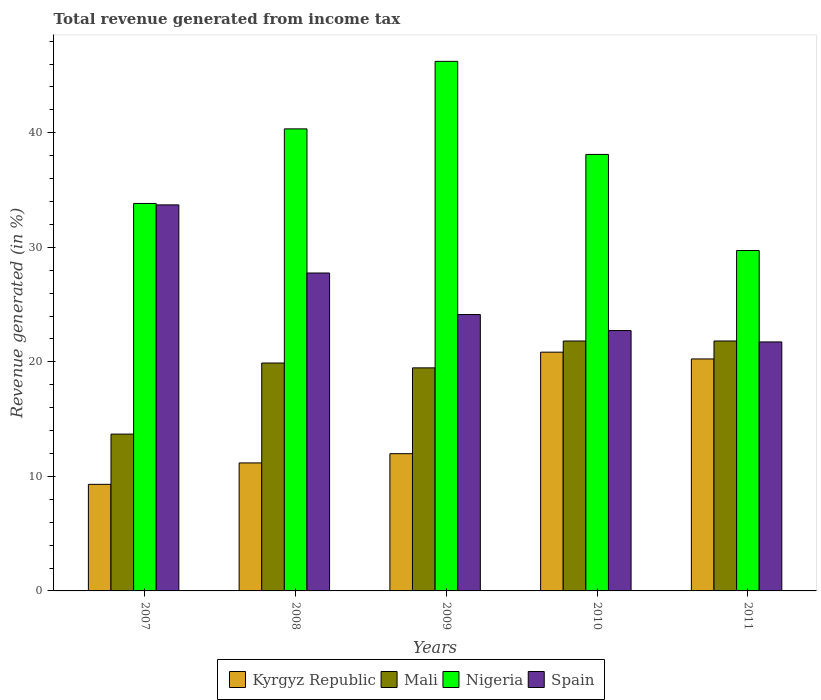Are the number of bars per tick equal to the number of legend labels?
Provide a succinct answer. Yes. Are the number of bars on each tick of the X-axis equal?
Offer a very short reply. Yes. How many bars are there on the 4th tick from the left?
Ensure brevity in your answer.  4. How many bars are there on the 3rd tick from the right?
Keep it short and to the point. 4. What is the label of the 3rd group of bars from the left?
Make the answer very short. 2009. What is the total revenue generated in Mali in 2010?
Keep it short and to the point. 21.82. Across all years, what is the maximum total revenue generated in Mali?
Offer a very short reply. 21.82. Across all years, what is the minimum total revenue generated in Kyrgyz Republic?
Keep it short and to the point. 9.31. What is the total total revenue generated in Spain in the graph?
Keep it short and to the point. 130.06. What is the difference between the total revenue generated in Nigeria in 2009 and that in 2011?
Your answer should be very brief. 16.51. What is the difference between the total revenue generated in Mali in 2011 and the total revenue generated in Kyrgyz Republic in 2009?
Ensure brevity in your answer.  9.84. What is the average total revenue generated in Kyrgyz Republic per year?
Give a very brief answer. 14.71. In the year 2008, what is the difference between the total revenue generated in Mali and total revenue generated in Nigeria?
Ensure brevity in your answer.  -20.44. What is the ratio of the total revenue generated in Nigeria in 2008 to that in 2010?
Your answer should be very brief. 1.06. Is the total revenue generated in Kyrgyz Republic in 2008 less than that in 2011?
Your answer should be compact. Yes. What is the difference between the highest and the second highest total revenue generated in Kyrgyz Republic?
Offer a terse response. 0.59. What is the difference between the highest and the lowest total revenue generated in Nigeria?
Keep it short and to the point. 16.51. In how many years, is the total revenue generated in Kyrgyz Republic greater than the average total revenue generated in Kyrgyz Republic taken over all years?
Offer a terse response. 2. What does the 3rd bar from the left in 2011 represents?
Provide a succinct answer. Nigeria. What does the 4th bar from the right in 2009 represents?
Offer a very short reply. Kyrgyz Republic. Is it the case that in every year, the sum of the total revenue generated in Mali and total revenue generated in Spain is greater than the total revenue generated in Nigeria?
Your answer should be compact. No. Are the values on the major ticks of Y-axis written in scientific E-notation?
Your response must be concise. No. Does the graph contain grids?
Make the answer very short. No. How many legend labels are there?
Your answer should be very brief. 4. What is the title of the graph?
Ensure brevity in your answer.  Total revenue generated from income tax. What is the label or title of the Y-axis?
Give a very brief answer. Revenue generated (in %). What is the Revenue generated (in %) in Kyrgyz Republic in 2007?
Offer a very short reply. 9.31. What is the Revenue generated (in %) of Mali in 2007?
Your answer should be compact. 13.69. What is the Revenue generated (in %) of Nigeria in 2007?
Keep it short and to the point. 33.83. What is the Revenue generated (in %) in Spain in 2007?
Offer a very short reply. 33.7. What is the Revenue generated (in %) in Kyrgyz Republic in 2008?
Provide a succinct answer. 11.17. What is the Revenue generated (in %) of Mali in 2008?
Your answer should be compact. 19.9. What is the Revenue generated (in %) in Nigeria in 2008?
Your response must be concise. 40.34. What is the Revenue generated (in %) in Spain in 2008?
Your response must be concise. 27.76. What is the Revenue generated (in %) in Kyrgyz Republic in 2009?
Provide a succinct answer. 11.98. What is the Revenue generated (in %) in Mali in 2009?
Provide a succinct answer. 19.47. What is the Revenue generated (in %) in Nigeria in 2009?
Your answer should be very brief. 46.23. What is the Revenue generated (in %) in Spain in 2009?
Ensure brevity in your answer.  24.13. What is the Revenue generated (in %) in Kyrgyz Republic in 2010?
Provide a succinct answer. 20.84. What is the Revenue generated (in %) in Mali in 2010?
Provide a succinct answer. 21.82. What is the Revenue generated (in %) of Nigeria in 2010?
Provide a short and direct response. 38.11. What is the Revenue generated (in %) of Spain in 2010?
Make the answer very short. 22.73. What is the Revenue generated (in %) of Kyrgyz Republic in 2011?
Offer a very short reply. 20.25. What is the Revenue generated (in %) in Mali in 2011?
Provide a short and direct response. 21.82. What is the Revenue generated (in %) of Nigeria in 2011?
Your answer should be compact. 29.72. What is the Revenue generated (in %) of Spain in 2011?
Make the answer very short. 21.74. Across all years, what is the maximum Revenue generated (in %) in Kyrgyz Republic?
Make the answer very short. 20.84. Across all years, what is the maximum Revenue generated (in %) of Mali?
Make the answer very short. 21.82. Across all years, what is the maximum Revenue generated (in %) of Nigeria?
Give a very brief answer. 46.23. Across all years, what is the maximum Revenue generated (in %) of Spain?
Your answer should be very brief. 33.7. Across all years, what is the minimum Revenue generated (in %) in Kyrgyz Republic?
Offer a terse response. 9.31. Across all years, what is the minimum Revenue generated (in %) in Mali?
Keep it short and to the point. 13.69. Across all years, what is the minimum Revenue generated (in %) in Nigeria?
Make the answer very short. 29.72. Across all years, what is the minimum Revenue generated (in %) in Spain?
Provide a short and direct response. 21.74. What is the total Revenue generated (in %) in Kyrgyz Republic in the graph?
Your answer should be compact. 73.56. What is the total Revenue generated (in %) of Mali in the graph?
Provide a short and direct response. 96.7. What is the total Revenue generated (in %) in Nigeria in the graph?
Your answer should be compact. 188.22. What is the total Revenue generated (in %) in Spain in the graph?
Offer a terse response. 130.06. What is the difference between the Revenue generated (in %) of Kyrgyz Republic in 2007 and that in 2008?
Ensure brevity in your answer.  -1.87. What is the difference between the Revenue generated (in %) in Mali in 2007 and that in 2008?
Give a very brief answer. -6.2. What is the difference between the Revenue generated (in %) of Nigeria in 2007 and that in 2008?
Your answer should be compact. -6.51. What is the difference between the Revenue generated (in %) in Spain in 2007 and that in 2008?
Give a very brief answer. 5.95. What is the difference between the Revenue generated (in %) of Kyrgyz Republic in 2007 and that in 2009?
Provide a succinct answer. -2.68. What is the difference between the Revenue generated (in %) in Mali in 2007 and that in 2009?
Keep it short and to the point. -5.78. What is the difference between the Revenue generated (in %) in Nigeria in 2007 and that in 2009?
Your answer should be compact. -12.41. What is the difference between the Revenue generated (in %) in Spain in 2007 and that in 2009?
Provide a succinct answer. 9.57. What is the difference between the Revenue generated (in %) in Kyrgyz Republic in 2007 and that in 2010?
Ensure brevity in your answer.  -11.54. What is the difference between the Revenue generated (in %) in Mali in 2007 and that in 2010?
Provide a succinct answer. -8.13. What is the difference between the Revenue generated (in %) of Nigeria in 2007 and that in 2010?
Your answer should be compact. -4.28. What is the difference between the Revenue generated (in %) of Spain in 2007 and that in 2010?
Your answer should be very brief. 10.97. What is the difference between the Revenue generated (in %) in Kyrgyz Republic in 2007 and that in 2011?
Provide a short and direct response. -10.95. What is the difference between the Revenue generated (in %) of Mali in 2007 and that in 2011?
Offer a very short reply. -8.13. What is the difference between the Revenue generated (in %) of Nigeria in 2007 and that in 2011?
Provide a short and direct response. 4.11. What is the difference between the Revenue generated (in %) of Spain in 2007 and that in 2011?
Provide a short and direct response. 11.97. What is the difference between the Revenue generated (in %) in Kyrgyz Republic in 2008 and that in 2009?
Keep it short and to the point. -0.81. What is the difference between the Revenue generated (in %) of Mali in 2008 and that in 2009?
Offer a terse response. 0.42. What is the difference between the Revenue generated (in %) of Nigeria in 2008 and that in 2009?
Offer a very short reply. -5.9. What is the difference between the Revenue generated (in %) in Spain in 2008 and that in 2009?
Provide a succinct answer. 3.62. What is the difference between the Revenue generated (in %) of Kyrgyz Republic in 2008 and that in 2010?
Ensure brevity in your answer.  -9.67. What is the difference between the Revenue generated (in %) in Mali in 2008 and that in 2010?
Offer a terse response. -1.92. What is the difference between the Revenue generated (in %) in Nigeria in 2008 and that in 2010?
Your answer should be very brief. 2.23. What is the difference between the Revenue generated (in %) of Spain in 2008 and that in 2010?
Keep it short and to the point. 5.02. What is the difference between the Revenue generated (in %) of Kyrgyz Republic in 2008 and that in 2011?
Ensure brevity in your answer.  -9.08. What is the difference between the Revenue generated (in %) of Mali in 2008 and that in 2011?
Offer a very short reply. -1.92. What is the difference between the Revenue generated (in %) of Nigeria in 2008 and that in 2011?
Keep it short and to the point. 10.62. What is the difference between the Revenue generated (in %) of Spain in 2008 and that in 2011?
Ensure brevity in your answer.  6.02. What is the difference between the Revenue generated (in %) in Kyrgyz Republic in 2009 and that in 2010?
Provide a succinct answer. -8.86. What is the difference between the Revenue generated (in %) of Mali in 2009 and that in 2010?
Give a very brief answer. -2.35. What is the difference between the Revenue generated (in %) of Nigeria in 2009 and that in 2010?
Your answer should be compact. 8.13. What is the difference between the Revenue generated (in %) in Spain in 2009 and that in 2010?
Offer a terse response. 1.4. What is the difference between the Revenue generated (in %) in Kyrgyz Republic in 2009 and that in 2011?
Keep it short and to the point. -8.27. What is the difference between the Revenue generated (in %) of Mali in 2009 and that in 2011?
Your response must be concise. -2.35. What is the difference between the Revenue generated (in %) in Nigeria in 2009 and that in 2011?
Give a very brief answer. 16.51. What is the difference between the Revenue generated (in %) in Spain in 2009 and that in 2011?
Your answer should be very brief. 2.39. What is the difference between the Revenue generated (in %) in Kyrgyz Republic in 2010 and that in 2011?
Offer a terse response. 0.59. What is the difference between the Revenue generated (in %) of Mali in 2010 and that in 2011?
Your answer should be very brief. -0. What is the difference between the Revenue generated (in %) in Nigeria in 2010 and that in 2011?
Provide a short and direct response. 8.39. What is the difference between the Revenue generated (in %) in Kyrgyz Republic in 2007 and the Revenue generated (in %) in Mali in 2008?
Your answer should be very brief. -10.59. What is the difference between the Revenue generated (in %) of Kyrgyz Republic in 2007 and the Revenue generated (in %) of Nigeria in 2008?
Your answer should be very brief. -31.03. What is the difference between the Revenue generated (in %) of Kyrgyz Republic in 2007 and the Revenue generated (in %) of Spain in 2008?
Make the answer very short. -18.45. What is the difference between the Revenue generated (in %) in Mali in 2007 and the Revenue generated (in %) in Nigeria in 2008?
Provide a short and direct response. -26.65. What is the difference between the Revenue generated (in %) of Mali in 2007 and the Revenue generated (in %) of Spain in 2008?
Your answer should be very brief. -14.06. What is the difference between the Revenue generated (in %) in Nigeria in 2007 and the Revenue generated (in %) in Spain in 2008?
Your answer should be compact. 6.07. What is the difference between the Revenue generated (in %) in Kyrgyz Republic in 2007 and the Revenue generated (in %) in Mali in 2009?
Keep it short and to the point. -10.17. What is the difference between the Revenue generated (in %) of Kyrgyz Republic in 2007 and the Revenue generated (in %) of Nigeria in 2009?
Provide a short and direct response. -36.93. What is the difference between the Revenue generated (in %) in Kyrgyz Republic in 2007 and the Revenue generated (in %) in Spain in 2009?
Your answer should be compact. -14.83. What is the difference between the Revenue generated (in %) of Mali in 2007 and the Revenue generated (in %) of Nigeria in 2009?
Provide a succinct answer. -32.54. What is the difference between the Revenue generated (in %) of Mali in 2007 and the Revenue generated (in %) of Spain in 2009?
Provide a succinct answer. -10.44. What is the difference between the Revenue generated (in %) in Nigeria in 2007 and the Revenue generated (in %) in Spain in 2009?
Your answer should be compact. 9.7. What is the difference between the Revenue generated (in %) in Kyrgyz Republic in 2007 and the Revenue generated (in %) in Mali in 2010?
Offer a very short reply. -12.51. What is the difference between the Revenue generated (in %) of Kyrgyz Republic in 2007 and the Revenue generated (in %) of Nigeria in 2010?
Your response must be concise. -28.8. What is the difference between the Revenue generated (in %) of Kyrgyz Republic in 2007 and the Revenue generated (in %) of Spain in 2010?
Offer a terse response. -13.42. What is the difference between the Revenue generated (in %) of Mali in 2007 and the Revenue generated (in %) of Nigeria in 2010?
Provide a short and direct response. -24.42. What is the difference between the Revenue generated (in %) in Mali in 2007 and the Revenue generated (in %) in Spain in 2010?
Your answer should be compact. -9.04. What is the difference between the Revenue generated (in %) of Nigeria in 2007 and the Revenue generated (in %) of Spain in 2010?
Your answer should be compact. 11.1. What is the difference between the Revenue generated (in %) of Kyrgyz Republic in 2007 and the Revenue generated (in %) of Mali in 2011?
Your response must be concise. -12.51. What is the difference between the Revenue generated (in %) in Kyrgyz Republic in 2007 and the Revenue generated (in %) in Nigeria in 2011?
Ensure brevity in your answer.  -20.41. What is the difference between the Revenue generated (in %) in Kyrgyz Republic in 2007 and the Revenue generated (in %) in Spain in 2011?
Your response must be concise. -12.43. What is the difference between the Revenue generated (in %) in Mali in 2007 and the Revenue generated (in %) in Nigeria in 2011?
Ensure brevity in your answer.  -16.03. What is the difference between the Revenue generated (in %) of Mali in 2007 and the Revenue generated (in %) of Spain in 2011?
Your response must be concise. -8.05. What is the difference between the Revenue generated (in %) in Nigeria in 2007 and the Revenue generated (in %) in Spain in 2011?
Offer a very short reply. 12.09. What is the difference between the Revenue generated (in %) of Kyrgyz Republic in 2008 and the Revenue generated (in %) of Mali in 2009?
Keep it short and to the point. -8.3. What is the difference between the Revenue generated (in %) in Kyrgyz Republic in 2008 and the Revenue generated (in %) in Nigeria in 2009?
Keep it short and to the point. -35.06. What is the difference between the Revenue generated (in %) in Kyrgyz Republic in 2008 and the Revenue generated (in %) in Spain in 2009?
Your answer should be compact. -12.96. What is the difference between the Revenue generated (in %) of Mali in 2008 and the Revenue generated (in %) of Nigeria in 2009?
Your answer should be compact. -26.34. What is the difference between the Revenue generated (in %) in Mali in 2008 and the Revenue generated (in %) in Spain in 2009?
Your answer should be very brief. -4.23. What is the difference between the Revenue generated (in %) in Nigeria in 2008 and the Revenue generated (in %) in Spain in 2009?
Your answer should be compact. 16.21. What is the difference between the Revenue generated (in %) in Kyrgyz Republic in 2008 and the Revenue generated (in %) in Mali in 2010?
Ensure brevity in your answer.  -10.64. What is the difference between the Revenue generated (in %) in Kyrgyz Republic in 2008 and the Revenue generated (in %) in Nigeria in 2010?
Offer a very short reply. -26.93. What is the difference between the Revenue generated (in %) of Kyrgyz Republic in 2008 and the Revenue generated (in %) of Spain in 2010?
Provide a short and direct response. -11.56. What is the difference between the Revenue generated (in %) of Mali in 2008 and the Revenue generated (in %) of Nigeria in 2010?
Offer a very short reply. -18.21. What is the difference between the Revenue generated (in %) of Mali in 2008 and the Revenue generated (in %) of Spain in 2010?
Offer a terse response. -2.83. What is the difference between the Revenue generated (in %) of Nigeria in 2008 and the Revenue generated (in %) of Spain in 2010?
Give a very brief answer. 17.61. What is the difference between the Revenue generated (in %) of Kyrgyz Republic in 2008 and the Revenue generated (in %) of Mali in 2011?
Your response must be concise. -10.64. What is the difference between the Revenue generated (in %) of Kyrgyz Republic in 2008 and the Revenue generated (in %) of Nigeria in 2011?
Your answer should be very brief. -18.55. What is the difference between the Revenue generated (in %) in Kyrgyz Republic in 2008 and the Revenue generated (in %) in Spain in 2011?
Ensure brevity in your answer.  -10.56. What is the difference between the Revenue generated (in %) of Mali in 2008 and the Revenue generated (in %) of Nigeria in 2011?
Ensure brevity in your answer.  -9.82. What is the difference between the Revenue generated (in %) in Mali in 2008 and the Revenue generated (in %) in Spain in 2011?
Keep it short and to the point. -1.84. What is the difference between the Revenue generated (in %) in Nigeria in 2008 and the Revenue generated (in %) in Spain in 2011?
Provide a succinct answer. 18.6. What is the difference between the Revenue generated (in %) in Kyrgyz Republic in 2009 and the Revenue generated (in %) in Mali in 2010?
Provide a short and direct response. -9.84. What is the difference between the Revenue generated (in %) in Kyrgyz Republic in 2009 and the Revenue generated (in %) in Nigeria in 2010?
Make the answer very short. -26.13. What is the difference between the Revenue generated (in %) of Kyrgyz Republic in 2009 and the Revenue generated (in %) of Spain in 2010?
Your answer should be very brief. -10.75. What is the difference between the Revenue generated (in %) of Mali in 2009 and the Revenue generated (in %) of Nigeria in 2010?
Your answer should be very brief. -18.63. What is the difference between the Revenue generated (in %) in Mali in 2009 and the Revenue generated (in %) in Spain in 2010?
Make the answer very short. -3.26. What is the difference between the Revenue generated (in %) of Nigeria in 2009 and the Revenue generated (in %) of Spain in 2010?
Offer a terse response. 23.5. What is the difference between the Revenue generated (in %) in Kyrgyz Republic in 2009 and the Revenue generated (in %) in Mali in 2011?
Give a very brief answer. -9.84. What is the difference between the Revenue generated (in %) of Kyrgyz Republic in 2009 and the Revenue generated (in %) of Nigeria in 2011?
Your response must be concise. -17.74. What is the difference between the Revenue generated (in %) of Kyrgyz Republic in 2009 and the Revenue generated (in %) of Spain in 2011?
Your response must be concise. -9.76. What is the difference between the Revenue generated (in %) in Mali in 2009 and the Revenue generated (in %) in Nigeria in 2011?
Keep it short and to the point. -10.25. What is the difference between the Revenue generated (in %) of Mali in 2009 and the Revenue generated (in %) of Spain in 2011?
Ensure brevity in your answer.  -2.26. What is the difference between the Revenue generated (in %) of Nigeria in 2009 and the Revenue generated (in %) of Spain in 2011?
Keep it short and to the point. 24.5. What is the difference between the Revenue generated (in %) in Kyrgyz Republic in 2010 and the Revenue generated (in %) in Mali in 2011?
Ensure brevity in your answer.  -0.97. What is the difference between the Revenue generated (in %) of Kyrgyz Republic in 2010 and the Revenue generated (in %) of Nigeria in 2011?
Provide a short and direct response. -8.88. What is the difference between the Revenue generated (in %) of Kyrgyz Republic in 2010 and the Revenue generated (in %) of Spain in 2011?
Give a very brief answer. -0.89. What is the difference between the Revenue generated (in %) in Mali in 2010 and the Revenue generated (in %) in Nigeria in 2011?
Your response must be concise. -7.9. What is the difference between the Revenue generated (in %) in Mali in 2010 and the Revenue generated (in %) in Spain in 2011?
Keep it short and to the point. 0.08. What is the difference between the Revenue generated (in %) of Nigeria in 2010 and the Revenue generated (in %) of Spain in 2011?
Your response must be concise. 16.37. What is the average Revenue generated (in %) of Kyrgyz Republic per year?
Provide a succinct answer. 14.71. What is the average Revenue generated (in %) in Mali per year?
Make the answer very short. 19.34. What is the average Revenue generated (in %) in Nigeria per year?
Make the answer very short. 37.64. What is the average Revenue generated (in %) of Spain per year?
Provide a succinct answer. 26.01. In the year 2007, what is the difference between the Revenue generated (in %) of Kyrgyz Republic and Revenue generated (in %) of Mali?
Your answer should be very brief. -4.39. In the year 2007, what is the difference between the Revenue generated (in %) in Kyrgyz Republic and Revenue generated (in %) in Nigeria?
Keep it short and to the point. -24.52. In the year 2007, what is the difference between the Revenue generated (in %) of Kyrgyz Republic and Revenue generated (in %) of Spain?
Your answer should be very brief. -24.4. In the year 2007, what is the difference between the Revenue generated (in %) in Mali and Revenue generated (in %) in Nigeria?
Give a very brief answer. -20.13. In the year 2007, what is the difference between the Revenue generated (in %) in Mali and Revenue generated (in %) in Spain?
Offer a terse response. -20.01. In the year 2007, what is the difference between the Revenue generated (in %) in Nigeria and Revenue generated (in %) in Spain?
Give a very brief answer. 0.12. In the year 2008, what is the difference between the Revenue generated (in %) in Kyrgyz Republic and Revenue generated (in %) in Mali?
Make the answer very short. -8.72. In the year 2008, what is the difference between the Revenue generated (in %) in Kyrgyz Republic and Revenue generated (in %) in Nigeria?
Your answer should be compact. -29.16. In the year 2008, what is the difference between the Revenue generated (in %) of Kyrgyz Republic and Revenue generated (in %) of Spain?
Offer a terse response. -16.58. In the year 2008, what is the difference between the Revenue generated (in %) in Mali and Revenue generated (in %) in Nigeria?
Keep it short and to the point. -20.44. In the year 2008, what is the difference between the Revenue generated (in %) of Mali and Revenue generated (in %) of Spain?
Provide a short and direct response. -7.86. In the year 2008, what is the difference between the Revenue generated (in %) in Nigeria and Revenue generated (in %) in Spain?
Provide a short and direct response. 12.58. In the year 2009, what is the difference between the Revenue generated (in %) in Kyrgyz Republic and Revenue generated (in %) in Mali?
Your answer should be compact. -7.49. In the year 2009, what is the difference between the Revenue generated (in %) of Kyrgyz Republic and Revenue generated (in %) of Nigeria?
Provide a short and direct response. -34.25. In the year 2009, what is the difference between the Revenue generated (in %) of Kyrgyz Republic and Revenue generated (in %) of Spain?
Offer a very short reply. -12.15. In the year 2009, what is the difference between the Revenue generated (in %) of Mali and Revenue generated (in %) of Nigeria?
Ensure brevity in your answer.  -26.76. In the year 2009, what is the difference between the Revenue generated (in %) in Mali and Revenue generated (in %) in Spain?
Ensure brevity in your answer.  -4.66. In the year 2009, what is the difference between the Revenue generated (in %) in Nigeria and Revenue generated (in %) in Spain?
Keep it short and to the point. 22.1. In the year 2010, what is the difference between the Revenue generated (in %) of Kyrgyz Republic and Revenue generated (in %) of Mali?
Make the answer very short. -0.97. In the year 2010, what is the difference between the Revenue generated (in %) of Kyrgyz Republic and Revenue generated (in %) of Nigeria?
Your answer should be very brief. -17.26. In the year 2010, what is the difference between the Revenue generated (in %) in Kyrgyz Republic and Revenue generated (in %) in Spain?
Your answer should be compact. -1.89. In the year 2010, what is the difference between the Revenue generated (in %) in Mali and Revenue generated (in %) in Nigeria?
Offer a terse response. -16.29. In the year 2010, what is the difference between the Revenue generated (in %) of Mali and Revenue generated (in %) of Spain?
Your answer should be very brief. -0.91. In the year 2010, what is the difference between the Revenue generated (in %) of Nigeria and Revenue generated (in %) of Spain?
Provide a succinct answer. 15.38. In the year 2011, what is the difference between the Revenue generated (in %) of Kyrgyz Republic and Revenue generated (in %) of Mali?
Offer a terse response. -1.57. In the year 2011, what is the difference between the Revenue generated (in %) in Kyrgyz Republic and Revenue generated (in %) in Nigeria?
Keep it short and to the point. -9.47. In the year 2011, what is the difference between the Revenue generated (in %) of Kyrgyz Republic and Revenue generated (in %) of Spain?
Provide a succinct answer. -1.48. In the year 2011, what is the difference between the Revenue generated (in %) in Mali and Revenue generated (in %) in Nigeria?
Provide a succinct answer. -7.9. In the year 2011, what is the difference between the Revenue generated (in %) in Mali and Revenue generated (in %) in Spain?
Provide a succinct answer. 0.08. In the year 2011, what is the difference between the Revenue generated (in %) in Nigeria and Revenue generated (in %) in Spain?
Ensure brevity in your answer.  7.98. What is the ratio of the Revenue generated (in %) in Kyrgyz Republic in 2007 to that in 2008?
Make the answer very short. 0.83. What is the ratio of the Revenue generated (in %) in Mali in 2007 to that in 2008?
Provide a succinct answer. 0.69. What is the ratio of the Revenue generated (in %) of Nigeria in 2007 to that in 2008?
Make the answer very short. 0.84. What is the ratio of the Revenue generated (in %) of Spain in 2007 to that in 2008?
Offer a very short reply. 1.21. What is the ratio of the Revenue generated (in %) in Kyrgyz Republic in 2007 to that in 2009?
Provide a succinct answer. 0.78. What is the ratio of the Revenue generated (in %) of Mali in 2007 to that in 2009?
Give a very brief answer. 0.7. What is the ratio of the Revenue generated (in %) in Nigeria in 2007 to that in 2009?
Your answer should be very brief. 0.73. What is the ratio of the Revenue generated (in %) in Spain in 2007 to that in 2009?
Make the answer very short. 1.4. What is the ratio of the Revenue generated (in %) of Kyrgyz Republic in 2007 to that in 2010?
Make the answer very short. 0.45. What is the ratio of the Revenue generated (in %) in Mali in 2007 to that in 2010?
Your response must be concise. 0.63. What is the ratio of the Revenue generated (in %) of Nigeria in 2007 to that in 2010?
Your answer should be very brief. 0.89. What is the ratio of the Revenue generated (in %) of Spain in 2007 to that in 2010?
Ensure brevity in your answer.  1.48. What is the ratio of the Revenue generated (in %) in Kyrgyz Republic in 2007 to that in 2011?
Your answer should be compact. 0.46. What is the ratio of the Revenue generated (in %) in Mali in 2007 to that in 2011?
Provide a short and direct response. 0.63. What is the ratio of the Revenue generated (in %) in Nigeria in 2007 to that in 2011?
Offer a very short reply. 1.14. What is the ratio of the Revenue generated (in %) of Spain in 2007 to that in 2011?
Your answer should be very brief. 1.55. What is the ratio of the Revenue generated (in %) of Kyrgyz Republic in 2008 to that in 2009?
Your answer should be very brief. 0.93. What is the ratio of the Revenue generated (in %) of Mali in 2008 to that in 2009?
Give a very brief answer. 1.02. What is the ratio of the Revenue generated (in %) in Nigeria in 2008 to that in 2009?
Keep it short and to the point. 0.87. What is the ratio of the Revenue generated (in %) of Spain in 2008 to that in 2009?
Provide a short and direct response. 1.15. What is the ratio of the Revenue generated (in %) in Kyrgyz Republic in 2008 to that in 2010?
Ensure brevity in your answer.  0.54. What is the ratio of the Revenue generated (in %) of Mali in 2008 to that in 2010?
Keep it short and to the point. 0.91. What is the ratio of the Revenue generated (in %) in Nigeria in 2008 to that in 2010?
Make the answer very short. 1.06. What is the ratio of the Revenue generated (in %) in Spain in 2008 to that in 2010?
Provide a succinct answer. 1.22. What is the ratio of the Revenue generated (in %) of Kyrgyz Republic in 2008 to that in 2011?
Keep it short and to the point. 0.55. What is the ratio of the Revenue generated (in %) of Mali in 2008 to that in 2011?
Make the answer very short. 0.91. What is the ratio of the Revenue generated (in %) of Nigeria in 2008 to that in 2011?
Your answer should be very brief. 1.36. What is the ratio of the Revenue generated (in %) of Spain in 2008 to that in 2011?
Keep it short and to the point. 1.28. What is the ratio of the Revenue generated (in %) of Kyrgyz Republic in 2009 to that in 2010?
Your answer should be very brief. 0.57. What is the ratio of the Revenue generated (in %) of Mali in 2009 to that in 2010?
Give a very brief answer. 0.89. What is the ratio of the Revenue generated (in %) in Nigeria in 2009 to that in 2010?
Make the answer very short. 1.21. What is the ratio of the Revenue generated (in %) of Spain in 2009 to that in 2010?
Provide a short and direct response. 1.06. What is the ratio of the Revenue generated (in %) of Kyrgyz Republic in 2009 to that in 2011?
Give a very brief answer. 0.59. What is the ratio of the Revenue generated (in %) in Mali in 2009 to that in 2011?
Your response must be concise. 0.89. What is the ratio of the Revenue generated (in %) of Nigeria in 2009 to that in 2011?
Keep it short and to the point. 1.56. What is the ratio of the Revenue generated (in %) of Spain in 2009 to that in 2011?
Keep it short and to the point. 1.11. What is the ratio of the Revenue generated (in %) in Kyrgyz Republic in 2010 to that in 2011?
Your answer should be compact. 1.03. What is the ratio of the Revenue generated (in %) in Nigeria in 2010 to that in 2011?
Your response must be concise. 1.28. What is the ratio of the Revenue generated (in %) in Spain in 2010 to that in 2011?
Offer a very short reply. 1.05. What is the difference between the highest and the second highest Revenue generated (in %) of Kyrgyz Republic?
Make the answer very short. 0.59. What is the difference between the highest and the second highest Revenue generated (in %) of Nigeria?
Offer a terse response. 5.9. What is the difference between the highest and the second highest Revenue generated (in %) in Spain?
Provide a succinct answer. 5.95. What is the difference between the highest and the lowest Revenue generated (in %) of Kyrgyz Republic?
Offer a very short reply. 11.54. What is the difference between the highest and the lowest Revenue generated (in %) of Mali?
Your response must be concise. 8.13. What is the difference between the highest and the lowest Revenue generated (in %) in Nigeria?
Provide a short and direct response. 16.51. What is the difference between the highest and the lowest Revenue generated (in %) of Spain?
Your answer should be compact. 11.97. 